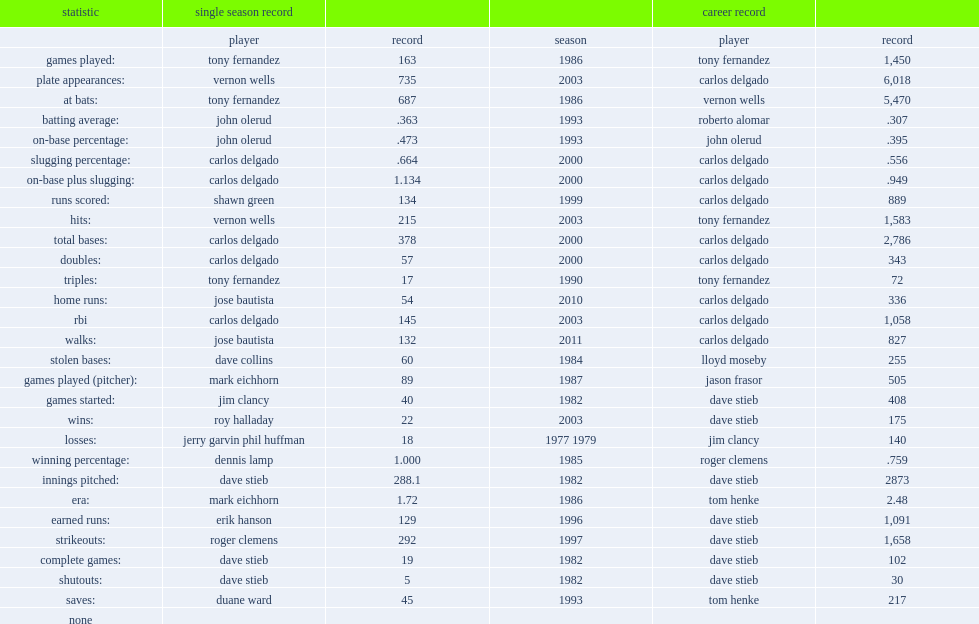I'm looking to parse the entire table for insights. Could you assist me with that? {'header': ['statistic', 'single season record', '', '', 'career record', ''], 'rows': [['', 'player', 'record', 'season', 'player', 'record'], ['games played:', 'tony fernandez', '163', '1986', 'tony fernandez', '1,450'], ['plate appearances:', 'vernon wells', '735', '2003', 'carlos delgado', '6,018'], ['at bats:', 'tony fernandez', '687', '1986', 'vernon wells', '5,470'], ['batting average:', 'john olerud', '.363', '1993', 'roberto alomar', '.307'], ['on-base percentage:', 'john olerud', '.473', '1993', 'john olerud', '.395'], ['slugging percentage:', 'carlos delgado', '.664', '2000', 'carlos delgado', '.556'], ['on-base plus slugging:', 'carlos delgado', '1.134', '2000', 'carlos delgado', '.949'], ['runs scored:', 'shawn green', '134', '1999', 'carlos delgado', '889'], ['hits:', 'vernon wells', '215', '2003', 'tony fernandez', '1,583'], ['total bases:', 'carlos delgado', '378', '2000', 'carlos delgado', '2,786'], ['doubles:', 'carlos delgado', '57', '2000', 'carlos delgado', '343'], ['triples:', 'tony fernandez', '17', '1990', 'tony fernandez', '72'], ['home runs:', 'jose bautista', '54', '2010', 'carlos delgado', '336'], ['rbi', 'carlos delgado', '145', '2003', 'carlos delgado', '1,058'], ['walks:', 'jose bautista', '132', '2011', 'carlos delgado', '827'], ['stolen bases:', 'dave collins', '60', '1984', 'lloyd moseby', '255'], ['games played (pitcher):', 'mark eichhorn', '89', '1987', 'jason frasor', '505'], ['games started:', 'jim clancy', '40', '1982', 'dave stieb', '408'], ['wins:', 'roy halladay', '22', '2003', 'dave stieb', '175'], ['losses:', 'jerry garvin phil huffman', '18', '1977 1979', 'jim clancy', '140'], ['winning percentage:', 'dennis lamp', '1.000', '1985', 'roger clemens', '.759'], ['innings pitched:', 'dave stieb', '288.1', '1982', 'dave stieb', '2873'], ['era:', 'mark eichhorn', '1.72', '1986', 'tom henke', '2.48'], ['earned runs:', 'erik hanson', '129', '1996', 'dave stieb', '1,091'], ['strikeouts:', 'roger clemens', '292', '1997', 'dave stieb', '1,658'], ['complete games:', 'dave stieb', '19', '1982', 'dave stieb', '102'], ['shutouts:', 'dave stieb', '5', '1982', 'dave stieb', '30'], ['saves:', 'duane ward', '45', '1993', 'tom henke', '217'], ['none', '', '', '', '', '']]} What is the record for jose bautista of the toronto blue jays's walk competition. 132.0. 